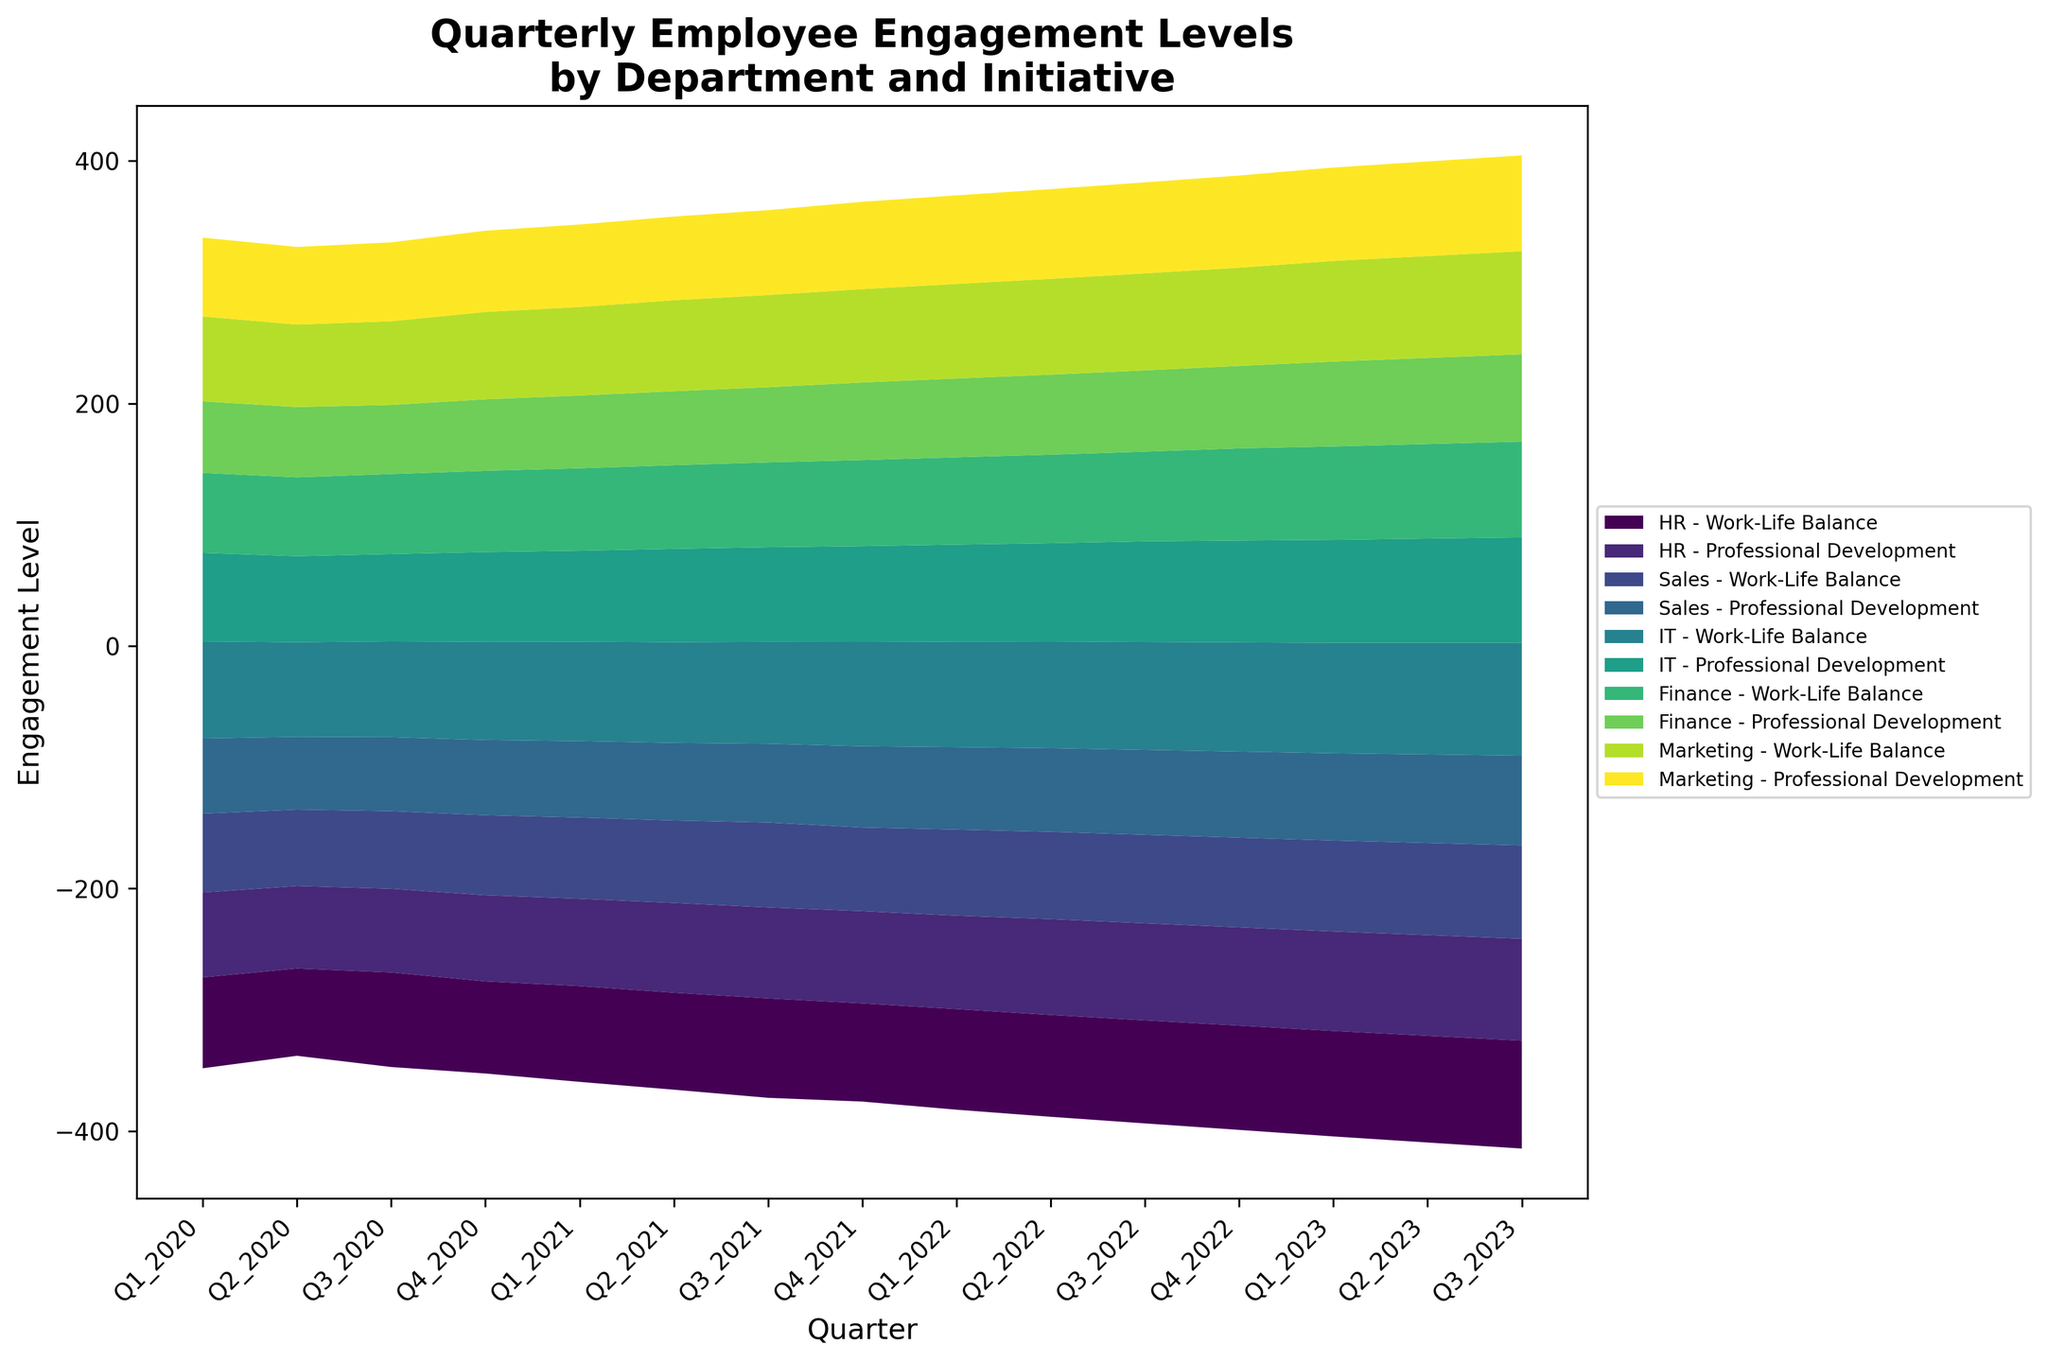What is the title of the figure? The title of the figure is displayed at the top and it reads "Quarterly Employee Engagement Levels by Department and Initiative".
Answer: Quarterly Employee Engagement Levels by Department and Initiative How many departments are included in the figure? The figure includes a stream graph with labels indicating different departments. Each department has multiple initiatives listed. By identifying unique department names in the labels, we see HR, Sales, IT, Finance, and Marketing, which count up to 5 departments.
Answer: 5 Which department has the highest engagement level for Work-Life Balance in Q3 2023? By looking at the colors and streams for each department in Q3 2023, we can identify which stack reaches the highest value. The IT department’s stream for Work-Life Balance peaks the highest in Q3 2023 based on the y-values.
Answer: IT What is the engagement level change for Marketing's Work-Life Balance from Q1 2020 to Q3 2023? First, locate the points for Marketing's Work-Life Balance in Q1 2020 and Q3 2023. The engagement level in Q1 2020 is 70 and in Q3 2023 is 85. The change is calculated as 85 - 70.
Answer: 15 Compare the engagement trends for Professional Development between HR and Finance. Which department shows greater improvement over the given period? Look at the streams for HR and Finance regarding Professional Development from Q1 2020 to Q3 2023. HR rises from 70 to 84, a difference of 14. Finance rises from 59 to 72, a difference of 13. HR shows slightly greater improvement.
Answer: HR Which initiative shows the least engagement level improvement in Sales from Q1 2020 to Q3 2023? By comparing values for Sales’ initiatives in Q1 2020 to Q3 2023, the Work-Life Balance goes from 65 to 77 (difference of 12) and Professional Development from 62 to 74 (difference of 12). Both have the same improvement.
Answer: Both initiatives Which Q3 quarter shows the highest overall engagement level across all departments and initiatives? Sum the engagement levels across all departments and initiatives for each Q3 quarter (Q3 2020, Q3 2021, Q3 2022, Q3 2023). The summed value is highest in Q3 2023, indicating that quarter had the highest overall engagement.
Answer: Q3 2023 How does HR's Work-Life Balance engagement level trend from Q1 2021 to Q4 2021? Observing the stream for HR’s Work-Life Balance from Q1 2021 (79) to Q4 2021 (81), it shows an increasing trend.
Answer: Increasing 